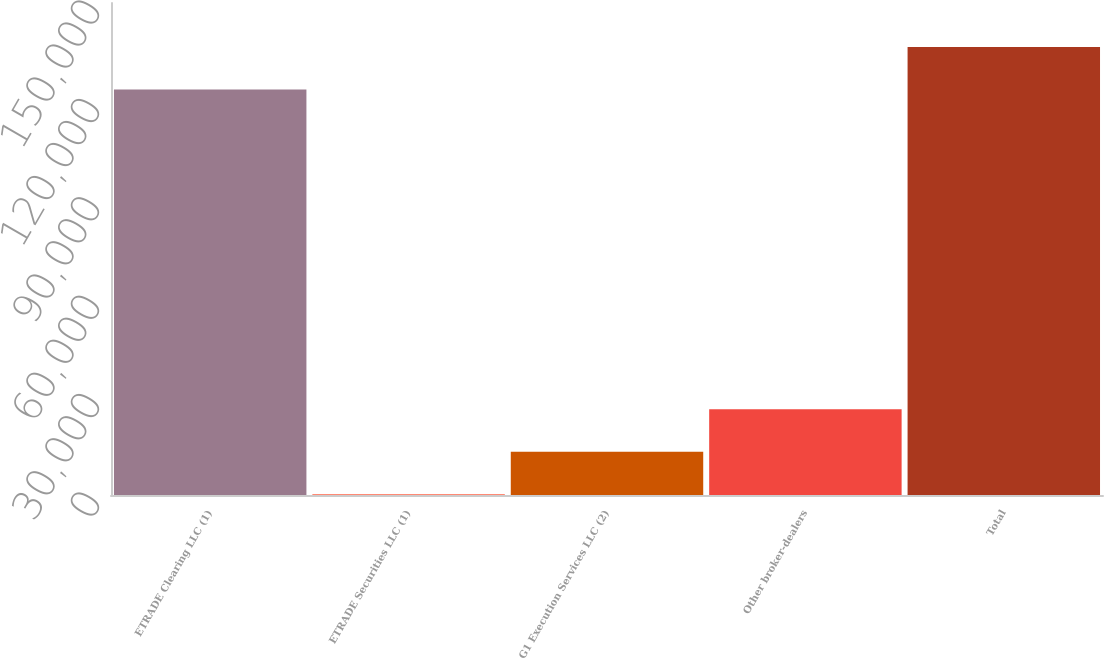<chart> <loc_0><loc_0><loc_500><loc_500><bar_chart><fcel>ETRADE Clearing LLC (1)<fcel>ETRADE Securities LLC (1)<fcel>G1 Execution Services LLC (2)<fcel>Other broker-dealers<fcel>Total<nl><fcel>123656<fcel>250<fcel>13207.8<fcel>26165.6<fcel>136614<nl></chart> 